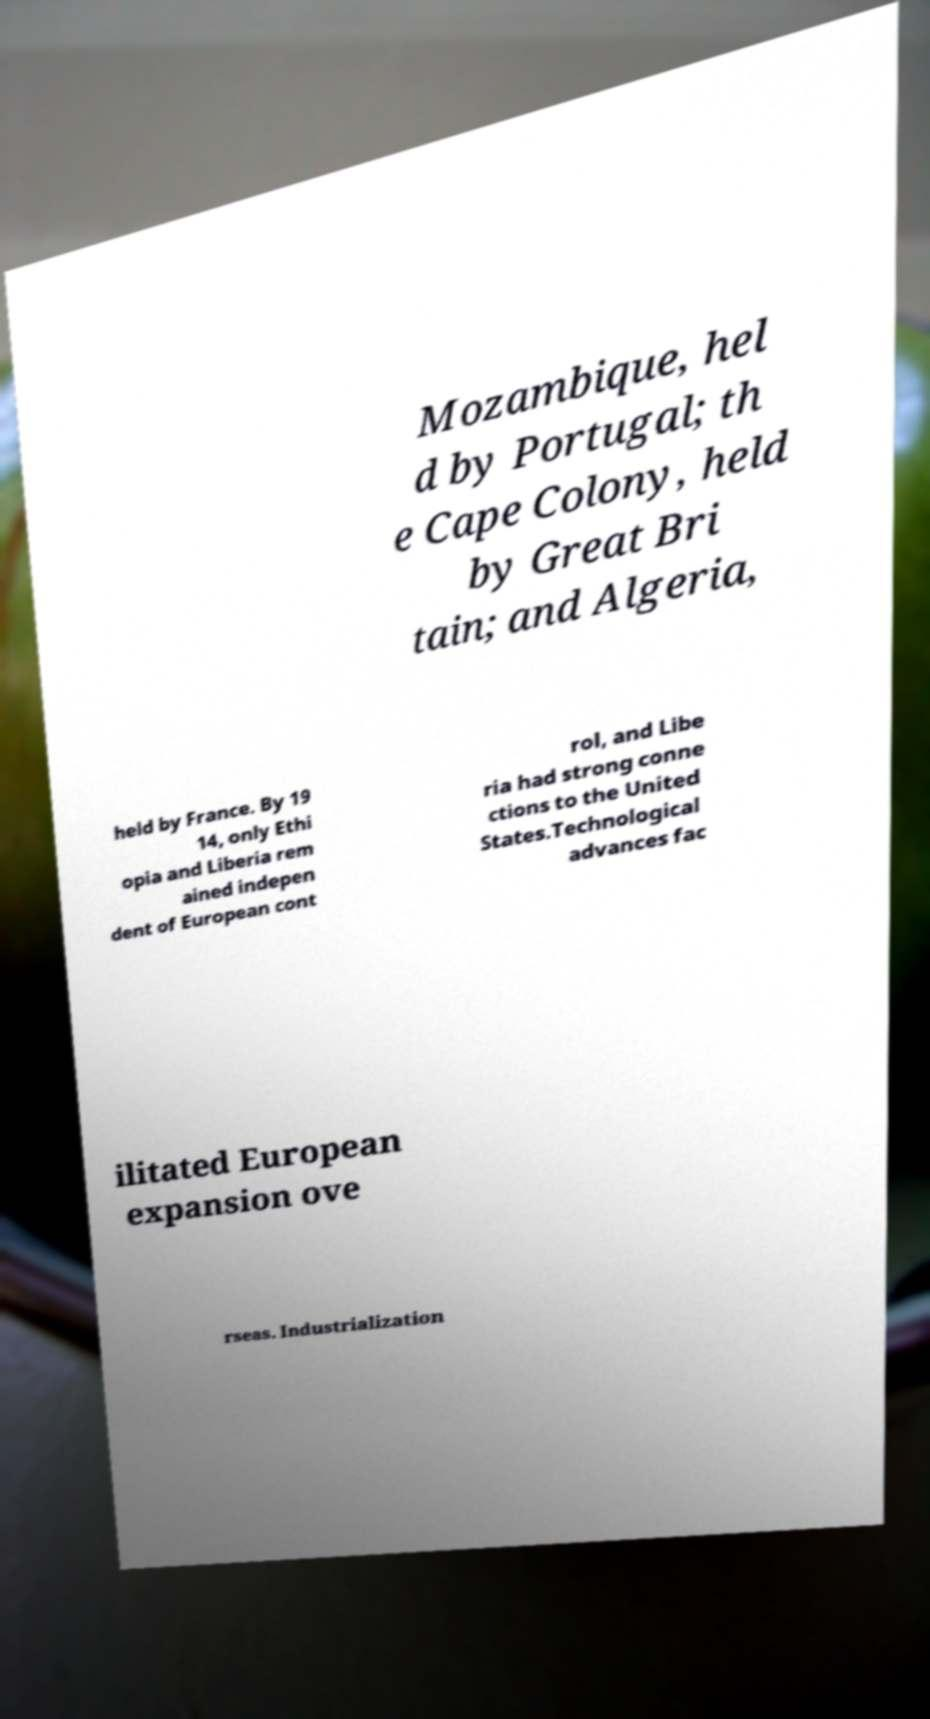I need the written content from this picture converted into text. Can you do that? Mozambique, hel d by Portugal; th e Cape Colony, held by Great Bri tain; and Algeria, held by France. By 19 14, only Ethi opia and Liberia rem ained indepen dent of European cont rol, and Libe ria had strong conne ctions to the United States.Technological advances fac ilitated European expansion ove rseas. Industrialization 